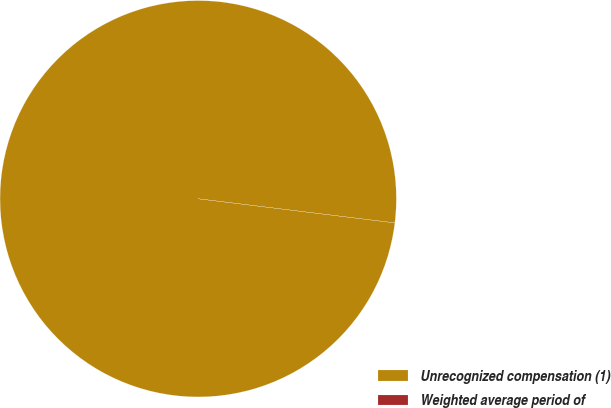<chart> <loc_0><loc_0><loc_500><loc_500><pie_chart><fcel>Unrecognized compensation (1)<fcel>Weighted average period of<nl><fcel>100.0%<fcel>0.0%<nl></chart> 